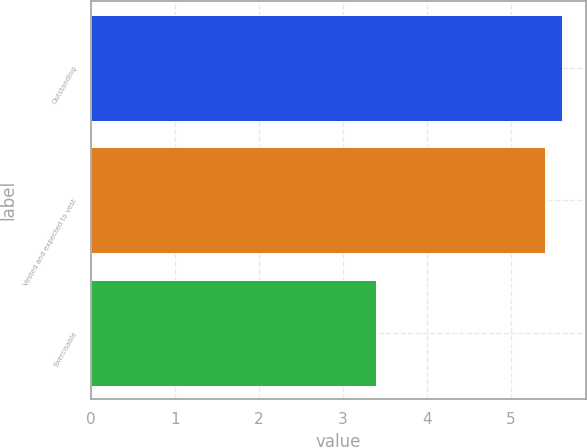Convert chart to OTSL. <chart><loc_0><loc_0><loc_500><loc_500><bar_chart><fcel>Outstanding<fcel>Vested and expected to vest<fcel>Exercisable<nl><fcel>5.61<fcel>5.4<fcel>3.4<nl></chart> 